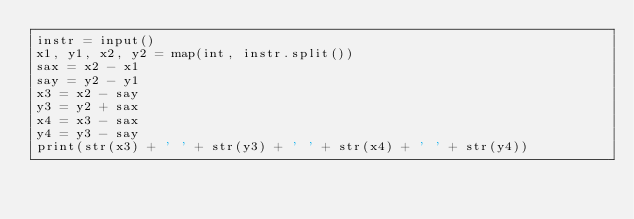<code> <loc_0><loc_0><loc_500><loc_500><_Python_>instr = input()
x1, y1, x2, y2 = map(int, instr.split())
sax = x2 - x1
say = y2 - y1
x3 = x2 - say
y3 = y2 + sax
x4 = x3 - sax
y4 = y3 - say
print(str(x3) + ' ' + str(y3) + ' ' + str(x4) + ' ' + str(y4))</code> 